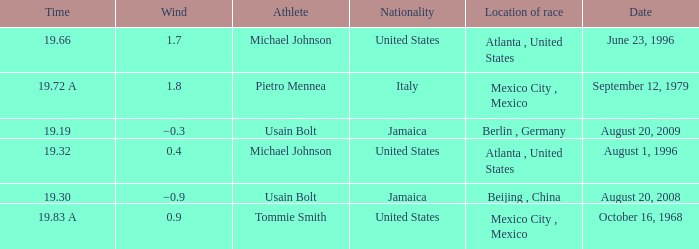What's the wind when the time was 19.32? 0.4. 